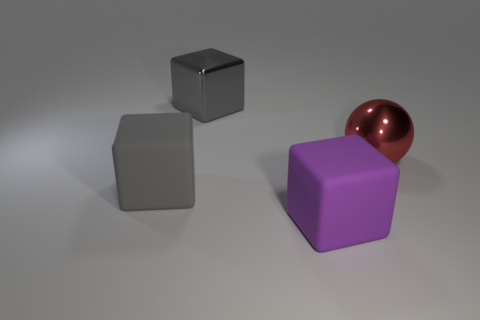Add 3 green metal cylinders. How many objects exist? 7 Subtract all purple blocks. How many blocks are left? 2 Subtract 2 cubes. How many cubes are left? 1 Subtract all spheres. How many objects are left? 3 Subtract all purple cubes. How many brown spheres are left? 0 Subtract all purple rubber balls. Subtract all gray matte objects. How many objects are left? 3 Add 1 rubber objects. How many rubber objects are left? 3 Add 4 large purple matte cubes. How many large purple matte cubes exist? 5 Subtract all gray cubes. How many cubes are left? 1 Subtract 0 brown cubes. How many objects are left? 4 